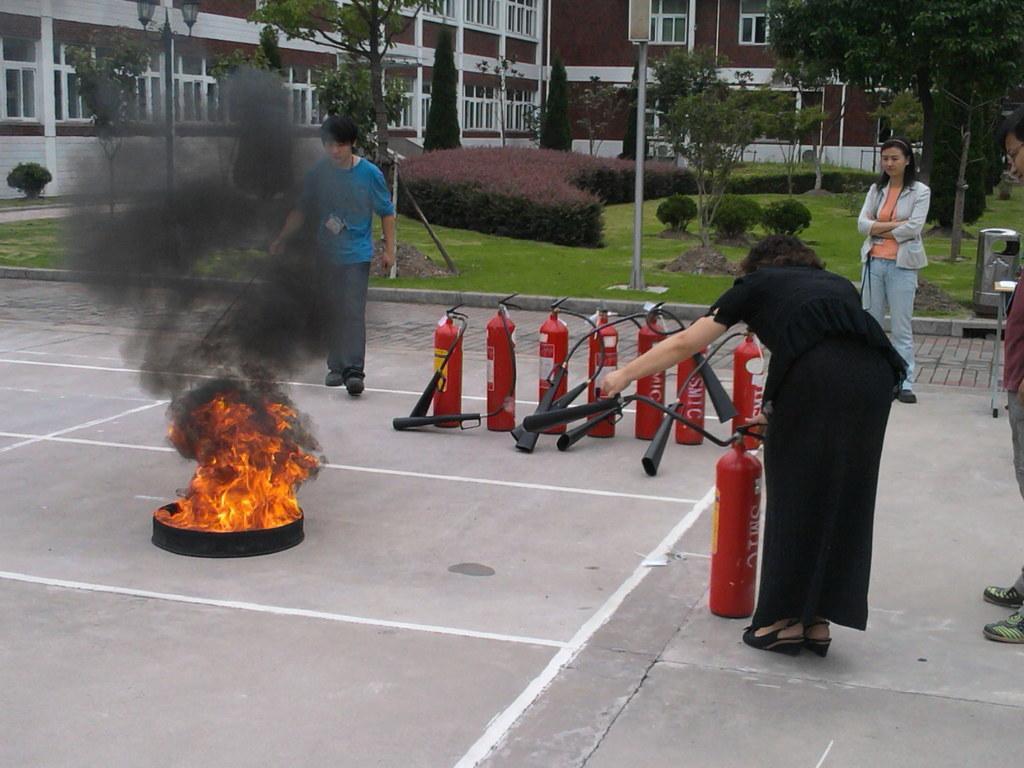Please provide a concise description of this image. In this image there is a fire in the middle and also there are some fire exhausters around also there are some people standing, beside them there are so many plants, grass and building. 